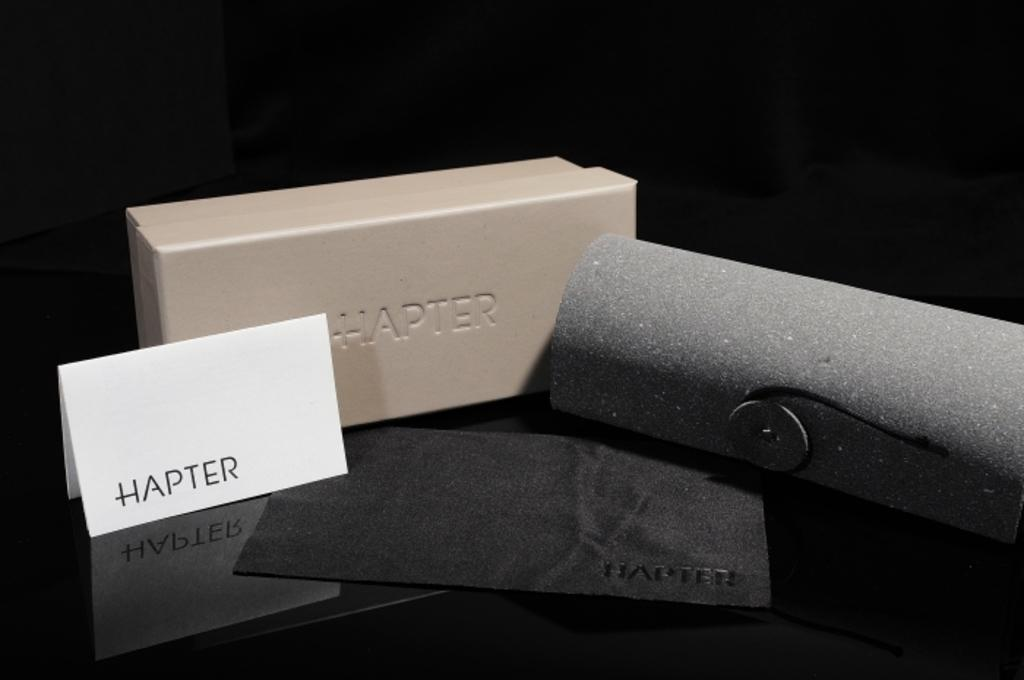<image>
Describe the image concisely. A small white Hapter display card and Hapter brand box are near a small black jewelry bag. 